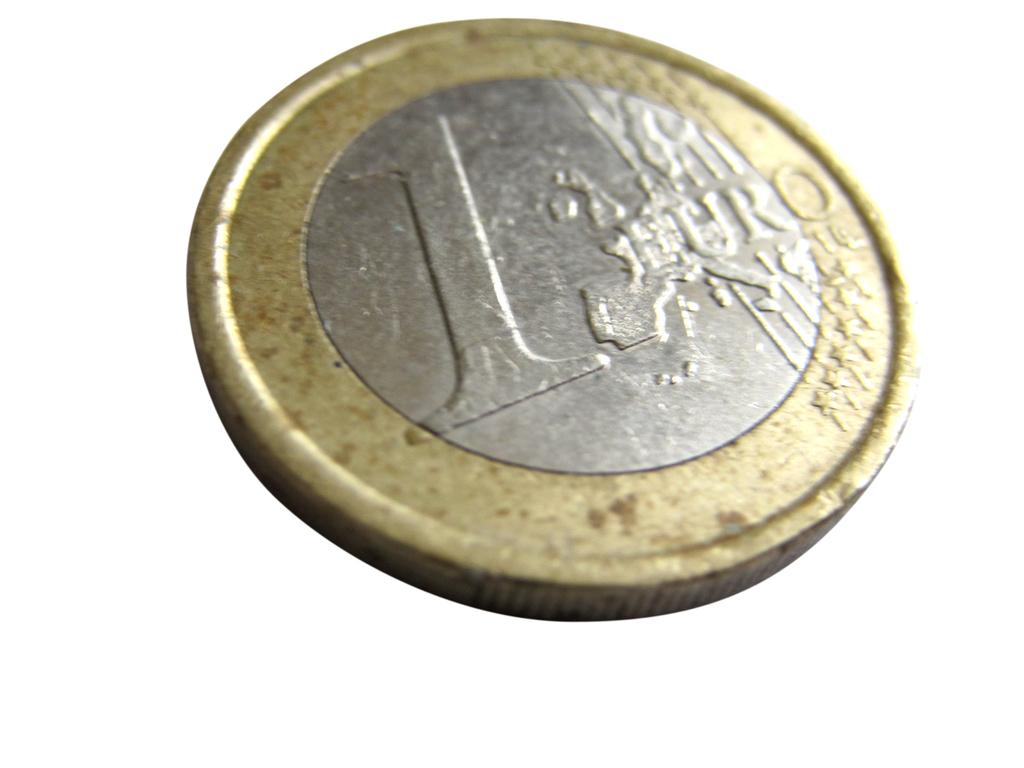How much is this coin worth?
Your answer should be very brief. 1 euro. What currency does this coin belong to?
Your answer should be compact. Euro. 